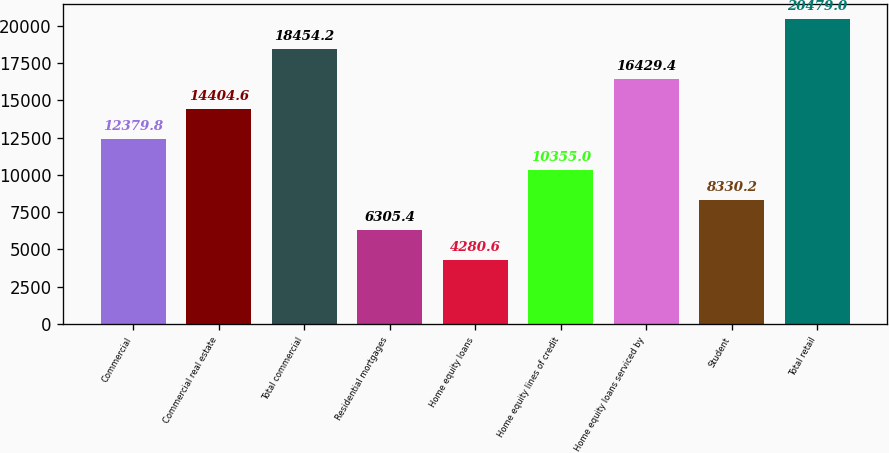Convert chart. <chart><loc_0><loc_0><loc_500><loc_500><bar_chart><fcel>Commercial<fcel>Commercial real estate<fcel>Total commercial<fcel>Residential mortgages<fcel>Home equity loans<fcel>Home equity lines of credit<fcel>Home equity loans serviced by<fcel>Student<fcel>Total retail<nl><fcel>12379.8<fcel>14404.6<fcel>18454.2<fcel>6305.4<fcel>4280.6<fcel>10355<fcel>16429.4<fcel>8330.2<fcel>20479<nl></chart> 